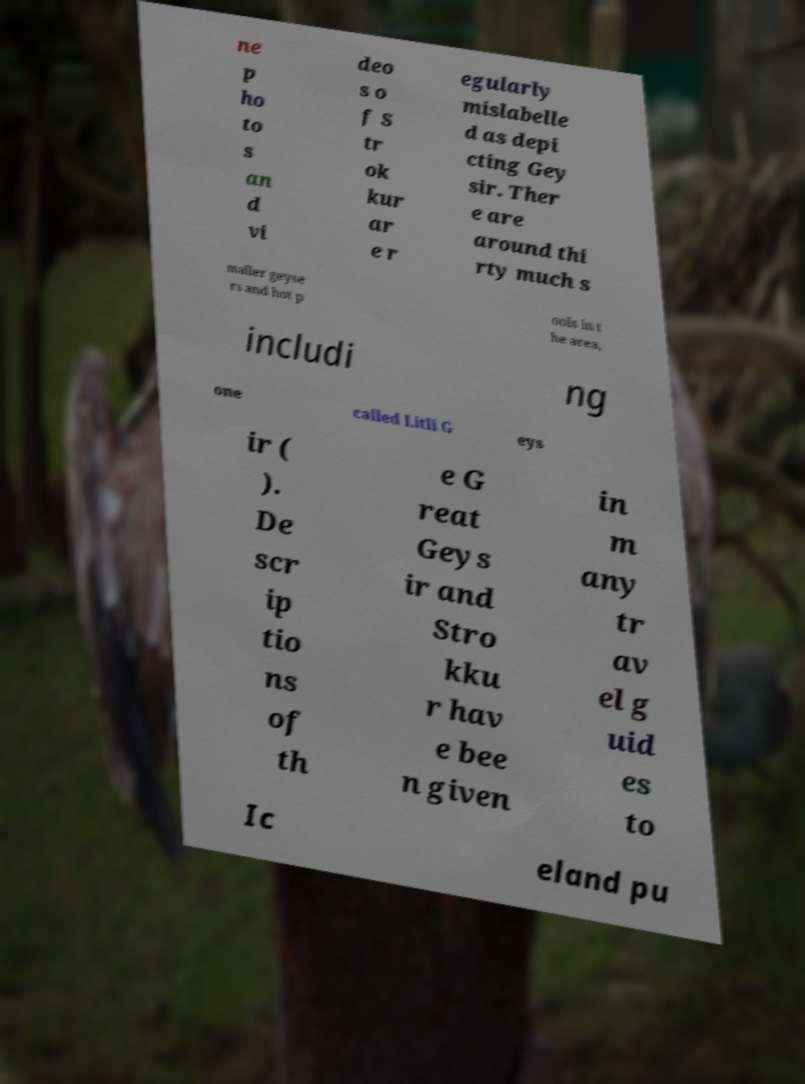There's text embedded in this image that I need extracted. Can you transcribe it verbatim? ne p ho to s an d vi deo s o f S tr ok kur ar e r egularly mislabelle d as depi cting Gey sir. Ther e are around thi rty much s maller geyse rs and hot p ools in t he area, includi ng one called Litli G eys ir ( ). De scr ip tio ns of th e G reat Geys ir and Stro kku r hav e bee n given in m any tr av el g uid es to Ic eland pu 